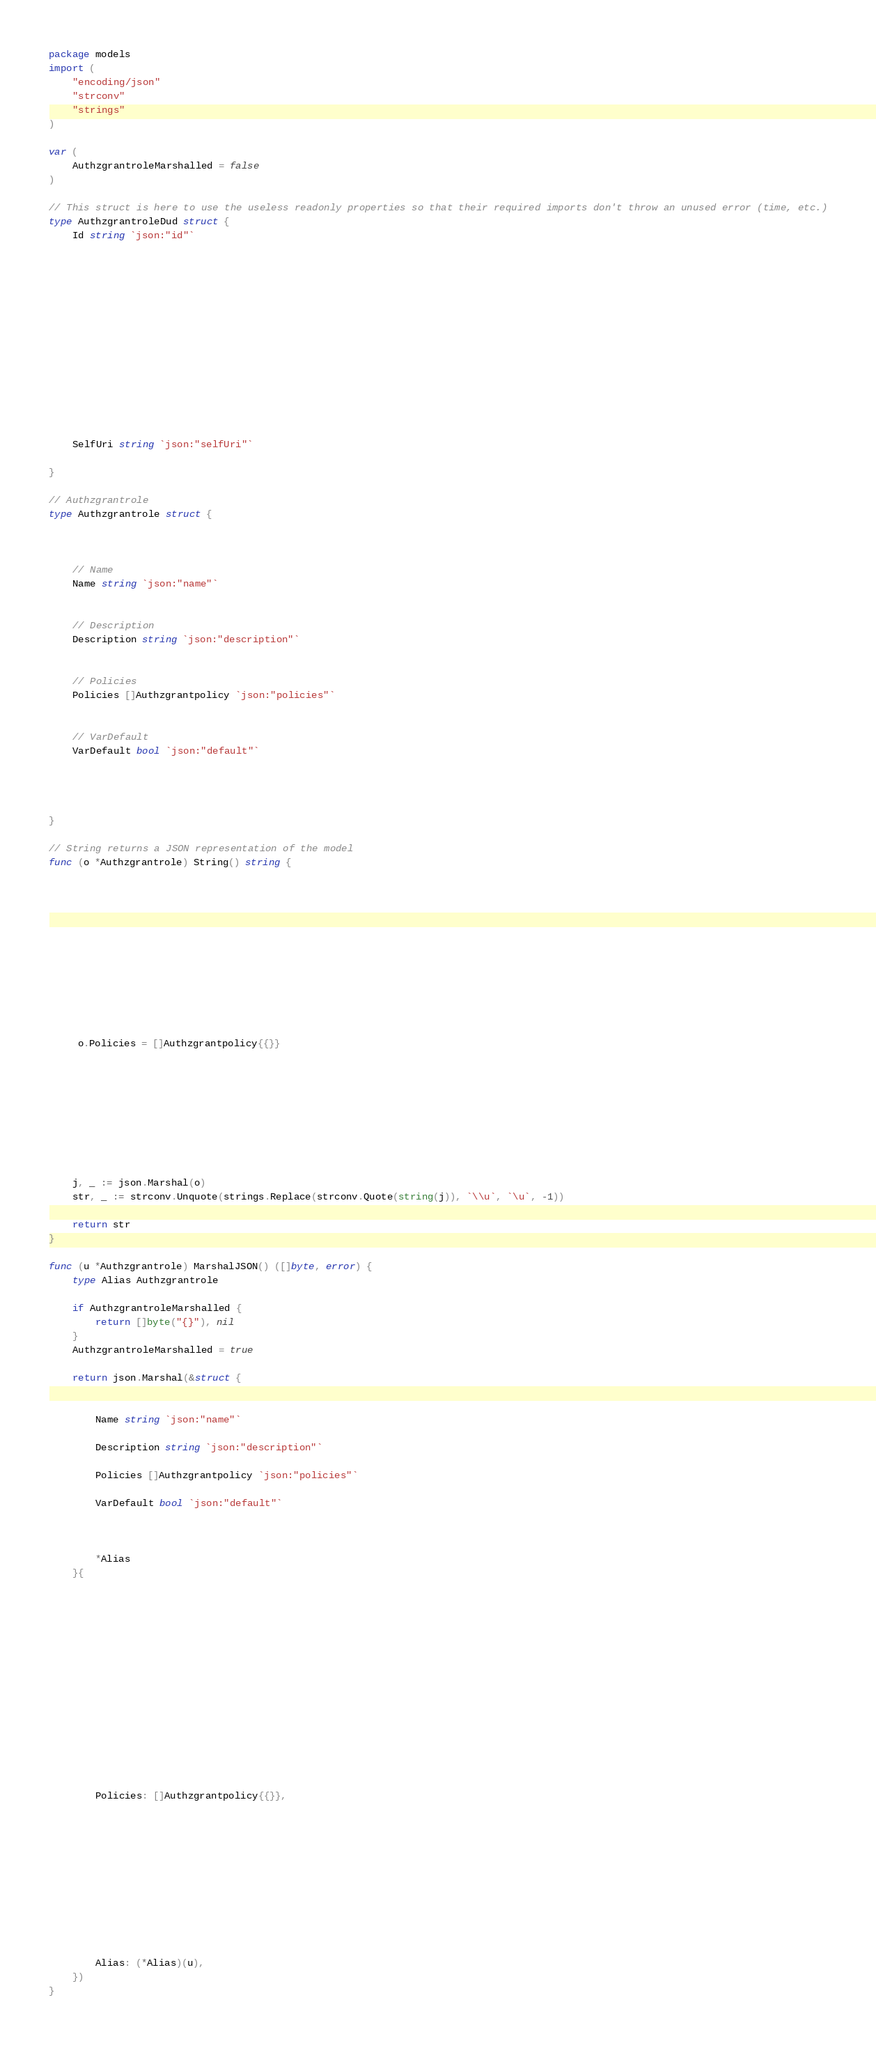<code> <loc_0><loc_0><loc_500><loc_500><_Go_>package models
import (
    "encoding/json"
    "strconv"
    "strings"
)

var (
    AuthzgrantroleMarshalled = false
)

// This struct is here to use the useless readonly properties so that their required imports don't throw an unused error (time, etc.)
type AuthzgrantroleDud struct { 
    Id string `json:"id"`


    


    


    


    


    SelfUri string `json:"selfUri"`

}

// Authzgrantrole
type Authzgrantrole struct { 
    


    // Name
    Name string `json:"name"`


    // Description
    Description string `json:"description"`


    // Policies
    Policies []Authzgrantpolicy `json:"policies"`


    // VarDefault
    VarDefault bool `json:"default"`


    

}

// String returns a JSON representation of the model
func (o *Authzgrantrole) String() string {
    
    
    
    
    
    
    
    
    
    
    
    
     o.Policies = []Authzgrantpolicy{{}} 
    
    
    
    
    
    
    
    

    j, _ := json.Marshal(o)
    str, _ := strconv.Unquote(strings.Replace(strconv.Quote(string(j)), `\\u`, `\u`, -1))

    return str
}

func (u *Authzgrantrole) MarshalJSON() ([]byte, error) {
    type Alias Authzgrantrole

    if AuthzgrantroleMarshalled {
        return []byte("{}"), nil
    }
    AuthzgrantroleMarshalled = true

    return json.Marshal(&struct { 
        
        
        Name string `json:"name"`
        
        Description string `json:"description"`
        
        Policies []Authzgrantpolicy `json:"policies"`
        
        VarDefault bool `json:"default"`
        
        
        
        *Alias
    }{
        

        

        

        

        

        

        

        
        Policies: []Authzgrantpolicy{{}},
        

        

        

        

        

        
        Alias: (*Alias)(u),
    })
}

</code> 